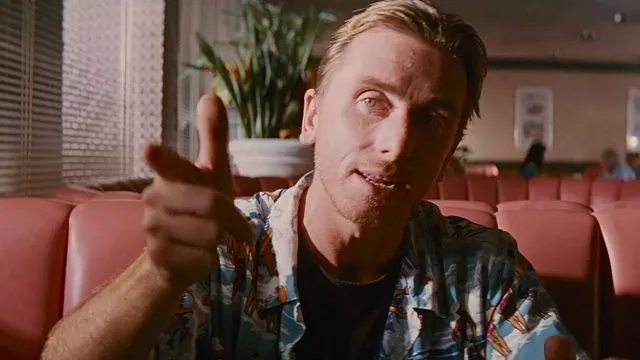What does the choice of clothing say about the character in this image? The vibrant Hawaiian shirt worn by the character in the image suggests a laid-back and perhaps unconventional personality. This choice of clothing sets him apart from a typical, more formally dressed character, hinting at a sense of individuality and perhaps a desire to defy expectations. Does the setting contribute to the character's portrayal? Absolutely, the diner setting enhances the character's relatability, placing him in a common, everyday environment. This setting can make the character appear more grounded and approachable, creating a contrast with any hidden or underlying aspects of his personality that may unfold in the narrative. 